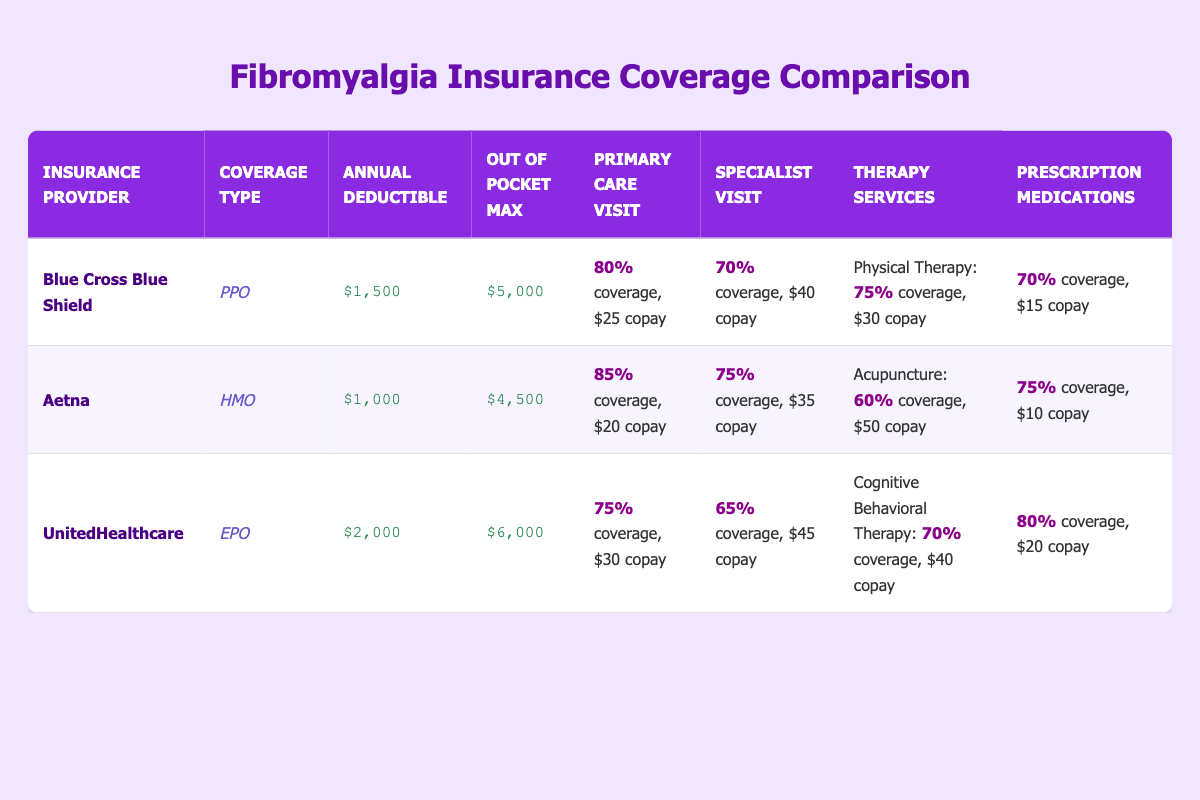What is the annual deductible for Aetna? The annual deductible for Aetna is listed directly in the table under the "Annual Deductible" column for Aetna, which shows $1,000.
Answer: $1,000 What is the out-of-pocket maximum for UnitedHealthcare? The out-of-pocket maximum for UnitedHealthcare can be found in the table under the "Out of Pocket Max" column for UnitedHealthcare, which shows $6,000.
Answer: $6,000 Which provider has the highest coverage percentage for Primary Care Visits? To find this, I compare the coverage percentage for Primary Care Visits across the three providers. Blue Cross Blue Shield offers 80%, Aetna offers 85%, and UnitedHealthcare offers 75%. Aetna has the highest rate of 85%.
Answer: Aetna Is the copay for Specialist Visits higher with Blue Cross Blue Shield or UnitedHealthcare? The copay for Specialist Visits is $40 for Blue Cross Blue Shield and $45 for UnitedHealthcare. Thus, UnitedHealthcare has a higher copay by comparing these two values directly.
Answer: UnitedHealthcare What is the average copay for Prescription Medications across all providers? I calculate the average by first identifying each provider's copay for Prescription Medications: $15 (Blue Cross Blue Shield), $10 (Aetna), and $20 (UnitedHealthcare). The sum is 15 + 10 + 20 = 45, and there are 3 providers, so the average is 45/3 = 15.
Answer: 15 Does Aetna provide coverage for Acupuncture services? The table shows that Aetna does list Acupuncture as one of its services, indicating that they provide coverage for it.
Answer: Yes Which provider has the lowest out-of-pocket maximum? By looking at the out-of-pocket maximums, Blue Cross Blue Shield has $5,000, Aetna $4,500, and UnitedHealthcare $6,000. Aetna has the lowest out-of-pocket maximum.
Answer: Aetna If you want to visit a Primary Care Physician and a Specialist in one day under Blue Cross Blue Shield, what would be the total copay? The copay for a Primary Care Visit under Blue Cross Blue Shield is $25 and for a Specialist Visit, it is $40. Adding these together gives a total copay of 25 + 40 = 65.
Answer: 65 What percentage of coverage does Aetna provide for Specialist Visits? To find the coverage percentage for Specialist Visits under Aetna, I refer to the table where it states Aetna offers 75% coverage for this service.
Answer: 75% 